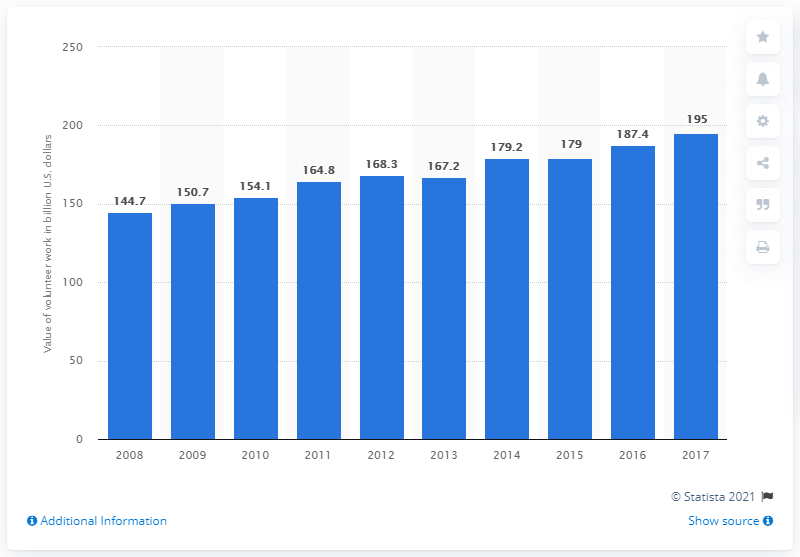Outline some significant characteristics in this image. In 2017, the value of volunteer time was estimated to be $24.14 per hour when converted to dollars, according to data from the Independent Sector, a nonprofit organization that tracks the value of volunteer time. This represents an increase from the previous year and reflects the growing importance of volunteer efforts in addressing societal issues and problems. 